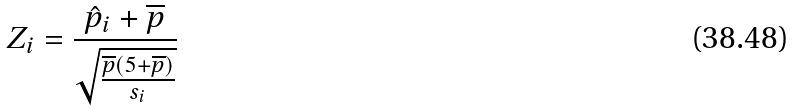<formula> <loc_0><loc_0><loc_500><loc_500>Z _ { i } = \frac { \hat { p } _ { i } + \overline { p } } { \sqrt { \frac { \overline { p } ( 5 + \overline { p } ) } { s _ { i } } } }</formula> 